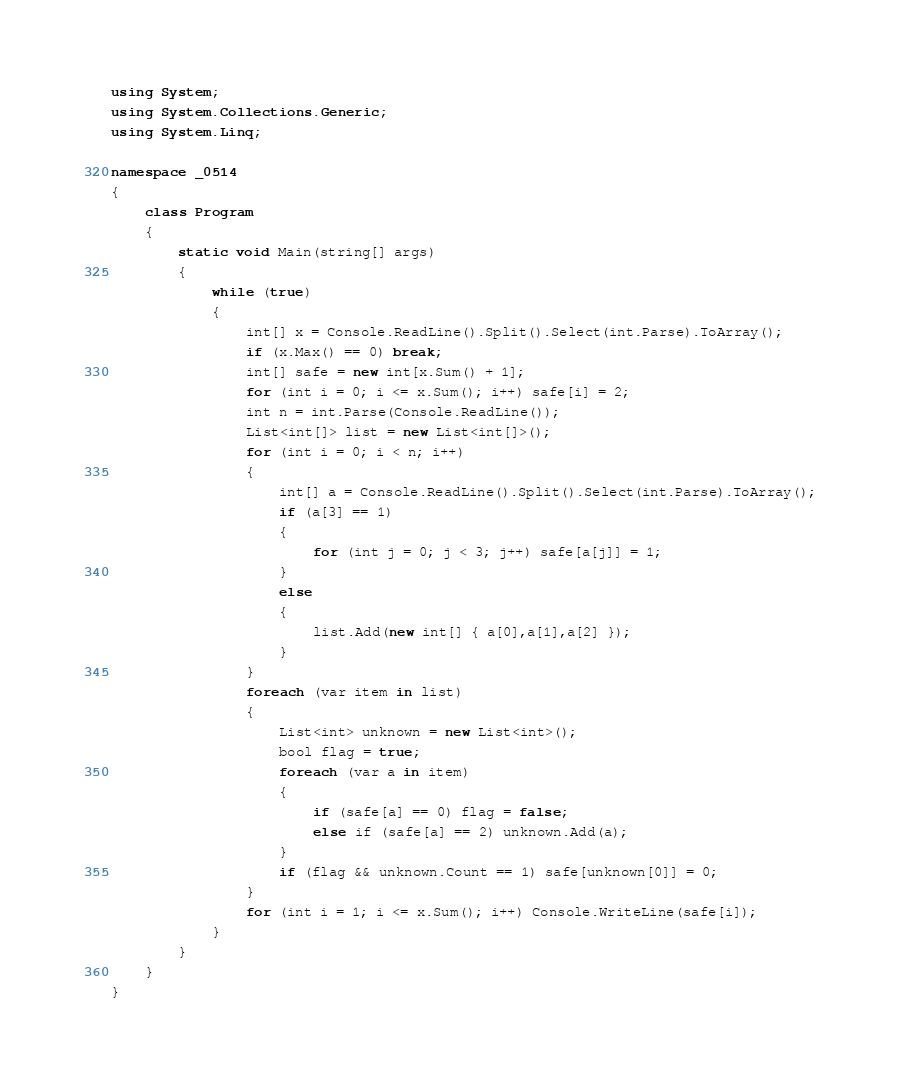<code> <loc_0><loc_0><loc_500><loc_500><_C#_>using System;
using System.Collections.Generic;
using System.Linq;

namespace _0514
{
    class Program
    {
        static void Main(string[] args)
        {
            while (true)
            {
                int[] x = Console.ReadLine().Split().Select(int.Parse).ToArray();
                if (x.Max() == 0) break;
                int[] safe = new int[x.Sum() + 1];
                for (int i = 0; i <= x.Sum(); i++) safe[i] = 2;
                int n = int.Parse(Console.ReadLine());
                List<int[]> list = new List<int[]>();
                for (int i = 0; i < n; i++)
                {
                    int[] a = Console.ReadLine().Split().Select(int.Parse).ToArray();
                    if (a[3] == 1)
                    {
                        for (int j = 0; j < 3; j++) safe[a[j]] = 1;
                    }
                    else
                    {
                        list.Add(new int[] { a[0],a[1],a[2] });
                    }
                }
                foreach (var item in list)
                {
                    List<int> unknown = new List<int>();
                    bool flag = true;
                    foreach (var a in item)
                    {
                        if (safe[a] == 0) flag = false;
                        else if (safe[a] == 2) unknown.Add(a);
                    }
                    if (flag && unknown.Count == 1) safe[unknown[0]] = 0;
                }
                for (int i = 1; i <= x.Sum(); i++) Console.WriteLine(safe[i]);
            }
        }
    }
}
</code> 